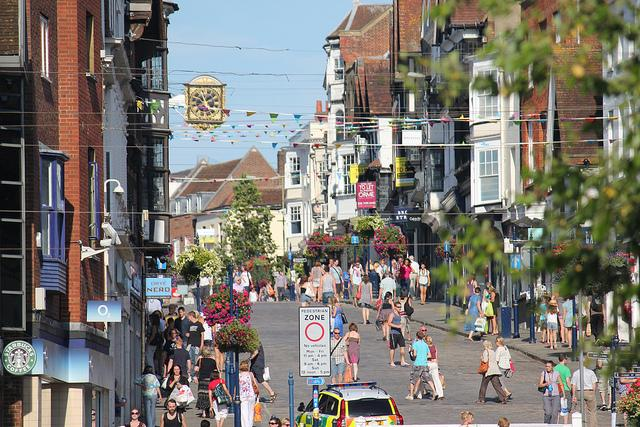What setting is this? Please explain your reasoning. city. This is the city street. 